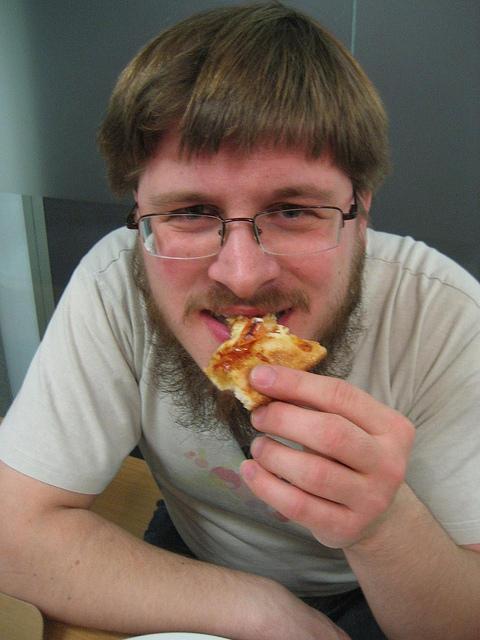How many giraffes are there?
Give a very brief answer. 0. 